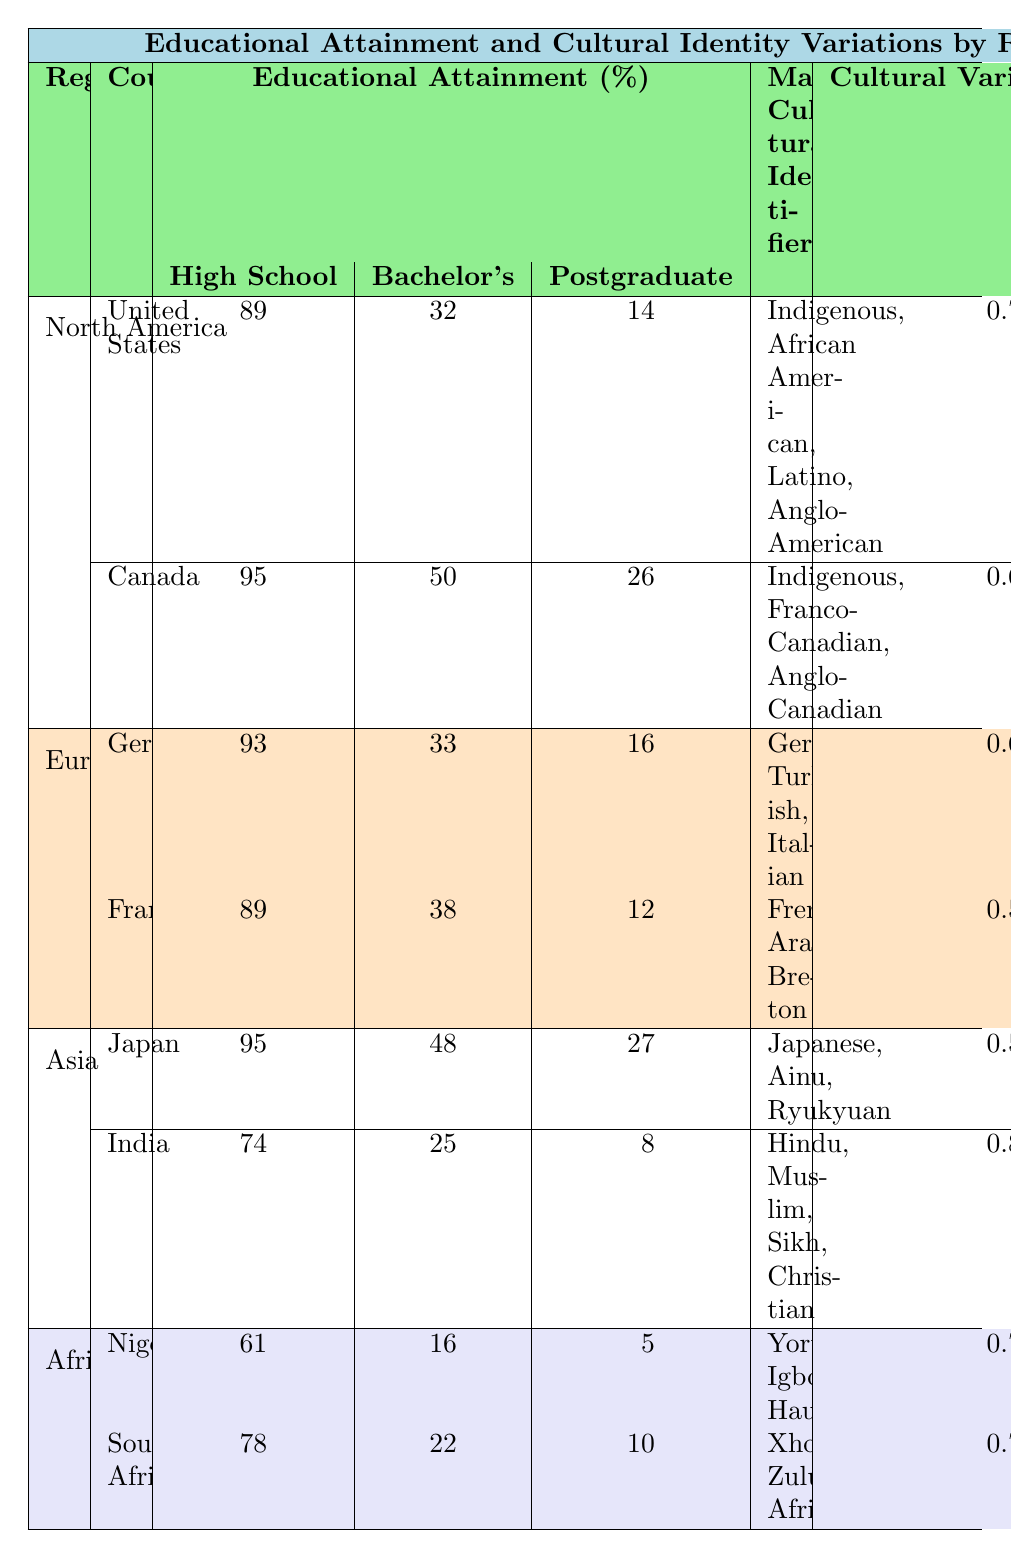What is the percentage of high school graduates in Canada? The table lists Canada under North America with an educational attainment percentage for high school graduates at 95%.
Answer: 95 Which country has the lowest percentage of postgraduate degrees in Africa? By looking at the educational attainment percentages for postgraduate degrees, Nigeria has 5%, which is lower than South Africa's 10%.
Answer: Nigeria What is the average percentage of bachelor's degrees across all the countries listed? The bachelor's degree percentages are 32, 50, 33, 38, 48, 25, 16, and 22 for the respective countries. Summing these gives 32 + 50 + 33 + 38 + 48 + 25 + 16 + 22 = 264. There are 8 countries, so the average is 264 / 8 = 33.
Answer: 33 Is the cultural variability index for India greater than that for Canada? India's cultural variability index is 0.8, while Canada's is 0.65. Since 0.8 is greater than 0.65, it is true.
Answer: Yes Which region has the highest percentage of high school graduates across its countries? North America has two countries listed: United States (89%) and Canada (95%). The highest percentage is in Canada at 95%. Other regions do not exceed this percentage.
Answer: North America What is the total percentage of high school graduates for countries in Europe? In Europe, Germany has 93% and France has 89% for high school graduates. Adding these yields 93 + 89 = 182%.
Answer: 182 Does the cultural variability index correlate with higher educational attainment percentages in any region? By observing the table, regions with higher educational attainment percentages, such as Canada (high school 95%, index 0.65) and Japan (high school 95%, index 0.5), do not necessarily show a consistent correlation with variability indices across all countries in their regions.
Answer: No Which country's educational attainment shows the largest difference between high school and bachelor degrees? India shows the largest difference: 74% for high school and 25% for bachelor's, resulting in a difference of 49%.
Answer: India 